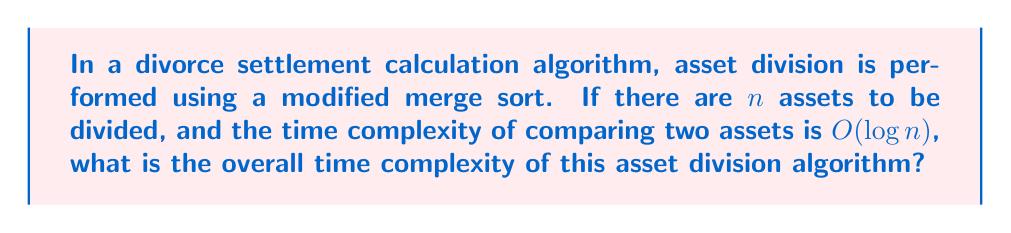What is the answer to this math problem? To solve this problem, we need to consider the structure of the merge sort algorithm and how the modified comparison affects its complexity:

1. Standard merge sort has a time complexity of $O(n \log n)$ for $n$ elements.

2. In a standard merge sort, the comparison step is usually $O(1)$. However, in this case, each comparison takes $O(\log n)$ time.

3. In merge sort, the number of comparisons is proportional to $n \log n$.

4. Therefore, we need to multiply the standard merge sort complexity by the complexity of each comparison:

   $O(n \log n) \cdot O(\log n) = O(n \log^2 n)$

This multiplication is valid because each comparison in the original algorithm is replaced by an $O(\log n)$ operation.

To break it down further:
- The outer $O(n \log n)$ comes from the merge sort structure.
- The inner $O(\log n)$ comes from the complexity of each comparison.
- When combined, we get $O(n \log n \cdot \log n) = O(n \log^2 n)$

This quadratic logarithmic time complexity indicates that the algorithm, while still efficient for large inputs, is slower than a standard merge sort due to the more complex comparisons required in divorce settlement calculations.
Answer: $O(n \log^2 n)$ 